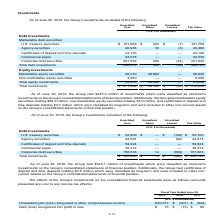According to Atlassian Plc's financial document, As of June 30, 2019, what is the value of the Group's marketable equity securities? According to the financial document, $58.9 million. The relevant text states: "he Group had marketable equity securities totaling $58.9 million, non-marketable equity securities totaling $3.0 million, and certificates of deposit and time depos..." Also, As of June 30, 2019, what is the value of the Group's non-marketable equity securities? According to the financial document, $3.0 million. The relevant text states: "million, non-marketable equity securities totaling $3.0 million, and certificates of deposit and time deposits totaling $3.7 million which were classified as long-..." Also, As of June 30, 2019, what is the value of the certificates of deposit and time deposits? According to the financial document, $3.7 million. The relevant text states: "certificates of deposit and time deposits totaling $3.7 million which were classified as long-term and were included in other non-current assets on the Group’s cons..." Also, can you calculate: What is the difference in the total debt investments and the total equity investments, based on amortized cost? Based on the calculation: 448,212-23,270, the result is 424942 (in thousands). This is based on the information: "Total equity investments 23,270 38,662 — 61,932 Total debt investments 448,212 528 (34) 448,706..." The key data points involved are: 23,270, 448,212. Also, can you calculate: Based on fair value, what is the percentage constitution of U.S. treasury securities among the total debt investments? Based on the calculation: 101,759/448,706, the result is 22.68 (percentage). This is based on the information: "U.S. treasury securities $ 101,563 $ 203 $ (7) 101,759 Total debt investments 448,212 528 (34) 448,706..." The key data points involved are: 101,759, 448,706. Also, can you calculate: Based on amortized cost, what is the percentage constitution of total equity investments among the total investments? Based on the calculation: 23,270/471,482, the result is 4.94 (percentage). This is based on the information: "Total equity investments 23,270 38,662 — 61,932 Total investments $ 471,482 $ 39,190 $ (34) $ 510,638..." The key data points involved are: 23,270, 471,482. 